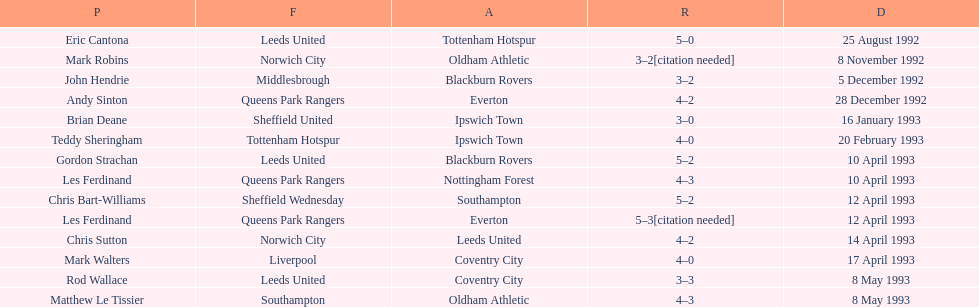Name the players for tottenham hotspur. Teddy Sheringham. 